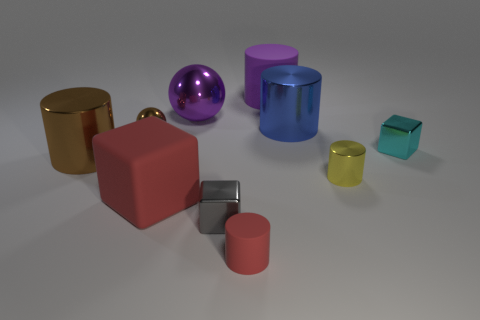There is a metal block that is right of the matte cylinder behind the small gray cube; what is its size?
Your answer should be compact. Small. What material is the red object that is the same size as the brown shiny cylinder?
Provide a succinct answer. Rubber. Are there any large purple objects made of the same material as the large red cube?
Offer a very short reply. Yes. What color is the big matte thing in front of the small cube behind the cylinder that is left of the large purple ball?
Make the answer very short. Red. There is a big metal cylinder to the left of the big red rubber thing; does it have the same color as the large rubber object on the left side of the purple rubber cylinder?
Provide a short and direct response. No. Is there anything else of the same color as the small sphere?
Your response must be concise. Yes. Is the number of large cylinders that are behind the brown metallic cylinder less than the number of brown shiny cylinders?
Your response must be concise. No. How many shiny cubes are there?
Your answer should be very brief. 2. Does the big purple shiny object have the same shape as the big matte thing behind the blue object?
Provide a short and direct response. No. Are there fewer big purple objects that are to the left of the large brown object than large purple things that are on the right side of the brown metal sphere?
Make the answer very short. Yes. 